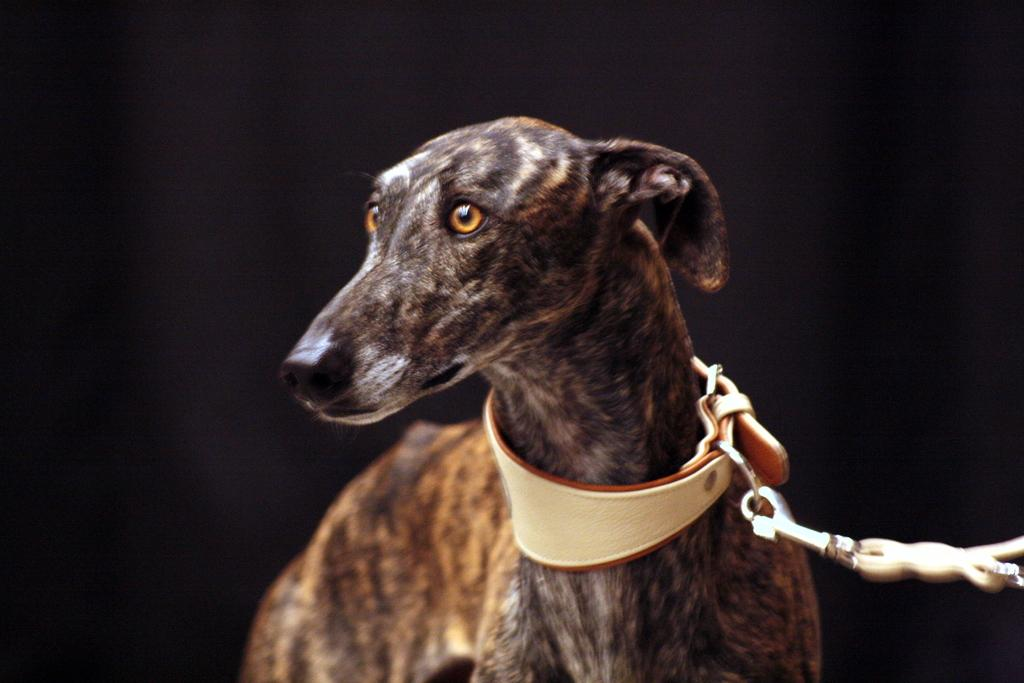What type of animal is in the image? There is a black dog in the image. What is the dog wearing? The dog has a belt. How is the belt connected to the dog? The belt is attached to a chain. What can be observed about the lighting in the image? The background of the image is dark. Where is the sink located in the image? There is no sink present in the image. What type of lunchroom can be seen in the image? There is no lunchroom present in the image. 